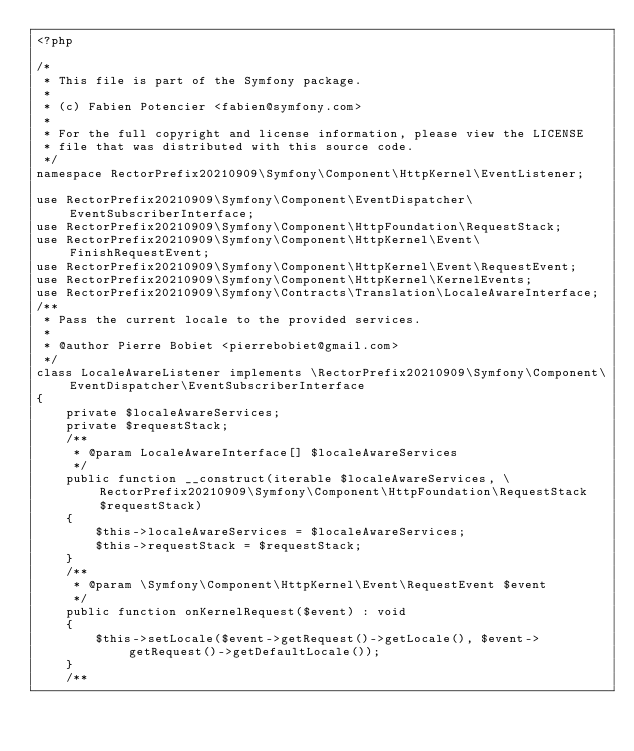<code> <loc_0><loc_0><loc_500><loc_500><_PHP_><?php

/*
 * This file is part of the Symfony package.
 *
 * (c) Fabien Potencier <fabien@symfony.com>
 *
 * For the full copyright and license information, please view the LICENSE
 * file that was distributed with this source code.
 */
namespace RectorPrefix20210909\Symfony\Component\HttpKernel\EventListener;

use RectorPrefix20210909\Symfony\Component\EventDispatcher\EventSubscriberInterface;
use RectorPrefix20210909\Symfony\Component\HttpFoundation\RequestStack;
use RectorPrefix20210909\Symfony\Component\HttpKernel\Event\FinishRequestEvent;
use RectorPrefix20210909\Symfony\Component\HttpKernel\Event\RequestEvent;
use RectorPrefix20210909\Symfony\Component\HttpKernel\KernelEvents;
use RectorPrefix20210909\Symfony\Contracts\Translation\LocaleAwareInterface;
/**
 * Pass the current locale to the provided services.
 *
 * @author Pierre Bobiet <pierrebobiet@gmail.com>
 */
class LocaleAwareListener implements \RectorPrefix20210909\Symfony\Component\EventDispatcher\EventSubscriberInterface
{
    private $localeAwareServices;
    private $requestStack;
    /**
     * @param LocaleAwareInterface[] $localeAwareServices
     */
    public function __construct(iterable $localeAwareServices, \RectorPrefix20210909\Symfony\Component\HttpFoundation\RequestStack $requestStack)
    {
        $this->localeAwareServices = $localeAwareServices;
        $this->requestStack = $requestStack;
    }
    /**
     * @param \Symfony\Component\HttpKernel\Event\RequestEvent $event
     */
    public function onKernelRequest($event) : void
    {
        $this->setLocale($event->getRequest()->getLocale(), $event->getRequest()->getDefaultLocale());
    }
    /**</code> 